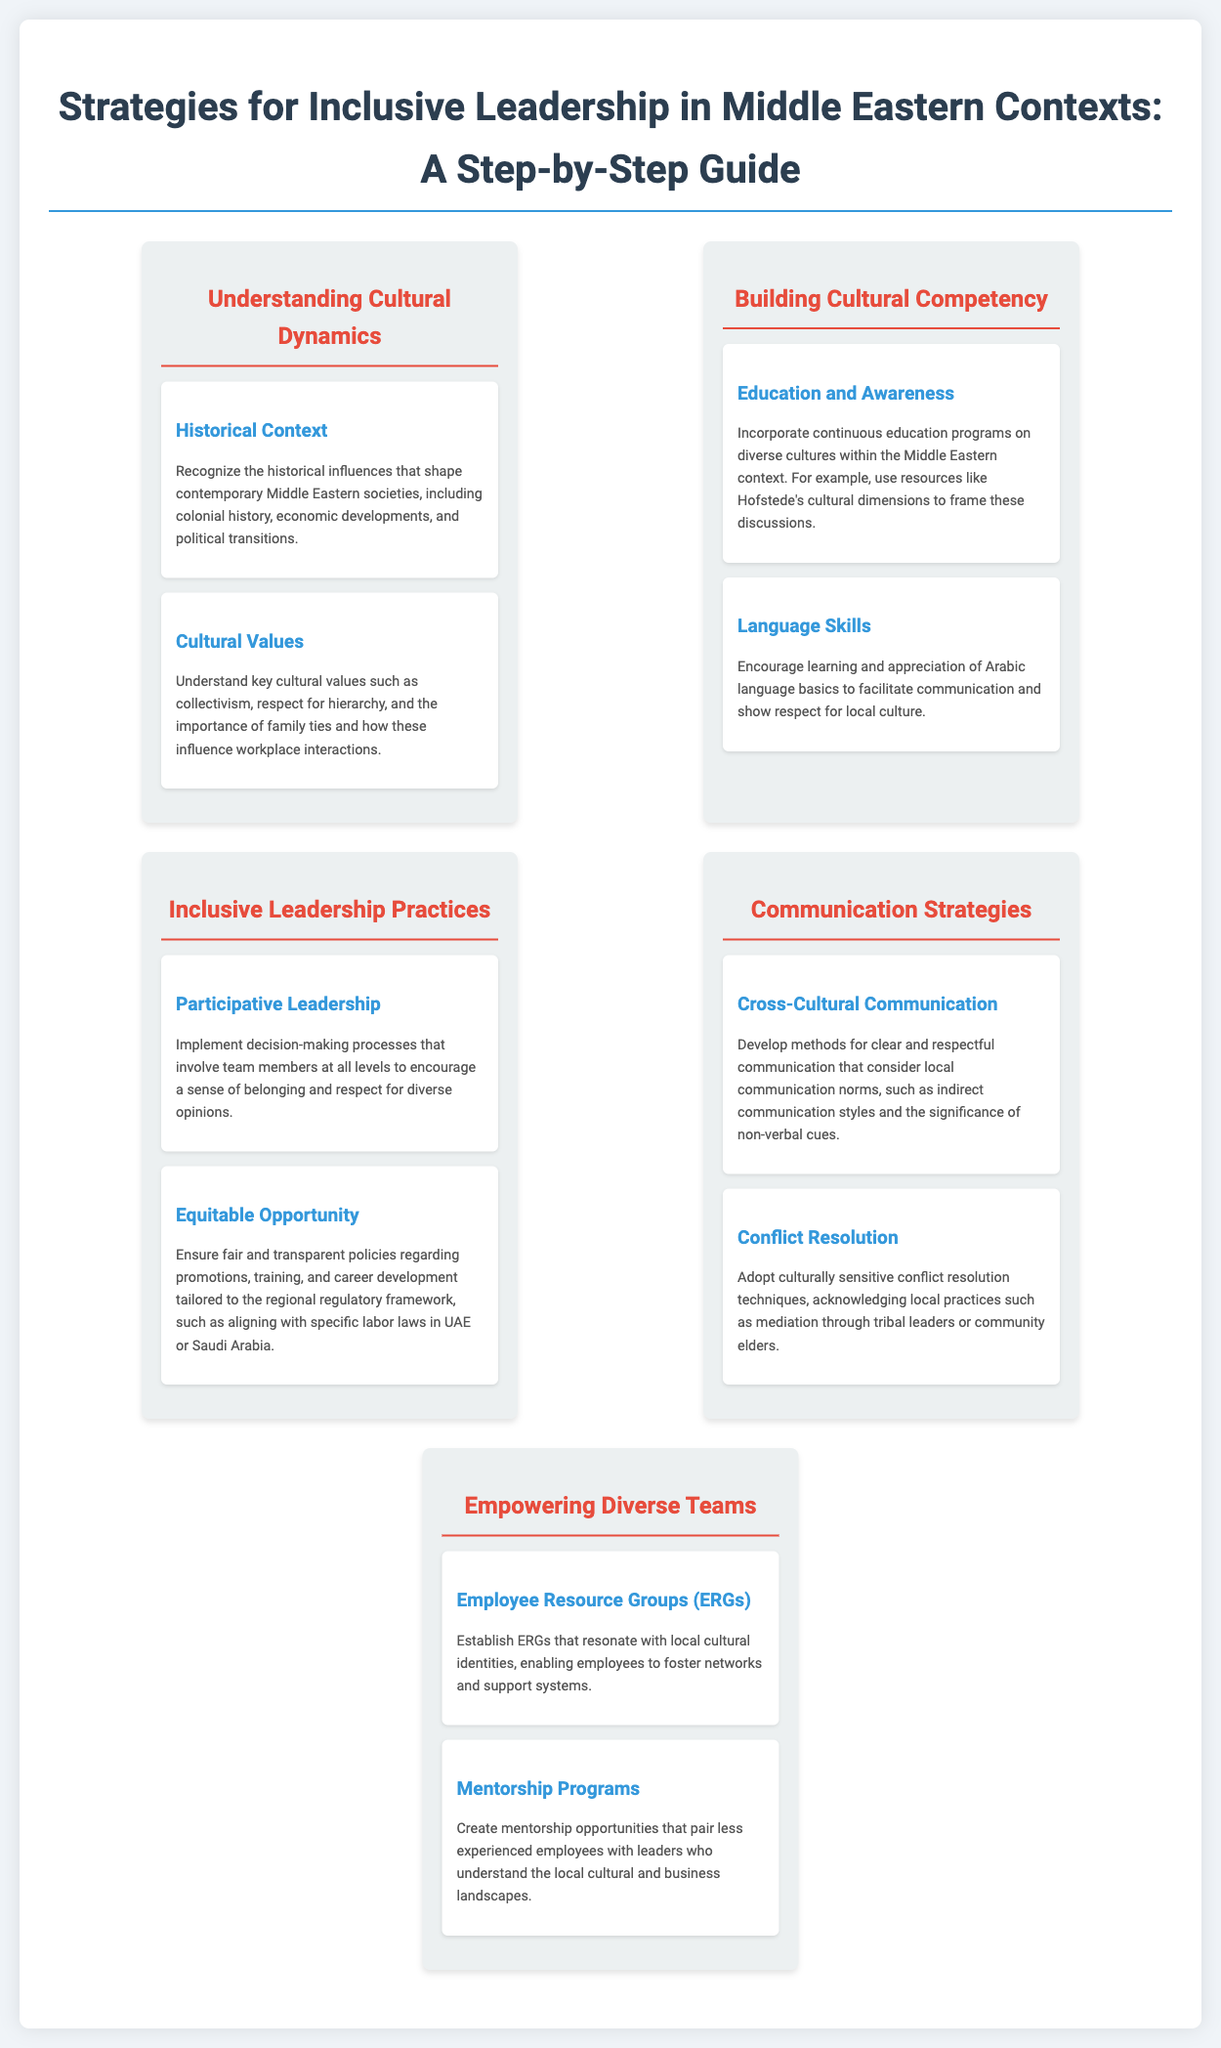What are the key cultural values? The document lists key cultural values such as collectivism, respect for hierarchy, and the importance of family ties, which influence workplace interactions.
Answer: collectivism, respect for hierarchy, importance of family ties What section discusses equitable opportunities? The section titled "Inclusive Leadership Practices" includes a step on ensuring equitable opportunity regarding promotions and training.
Answer: Inclusive Leadership Practices Which communication strategy should be developed according to the document? The document suggests developing methods for clear and respectful communication considering local communication norms.
Answer: Cross-Cultural Communication What is one method for conflict resolution mentioned? The document acknowledges the importance of adopting culturally sensitive conflict resolution techniques, including mediation through local practices.
Answer: mediation through tribal leaders How many sections are described in the infographic? The infographic contains five distinct sections outlining various strategies for inclusive leadership.
Answer: five What is the purpose of Employee Resource Groups? According to the document, ERGs facilitate networks and support systems that resonate with local cultural identities.
Answer: foster networks and support systems What educational resource is recommended for cultural competency? The document suggests using Hofstede's cultural dimensions as a resource for education and awareness in cultural competency.
Answer: Hofstede's cultural dimensions What type of leadership is encouraged in the document? The step "Participative Leadership" underlines the importance of involving team members in decision-making processes to promote inclusiveness.
Answer: Participative Leadership 